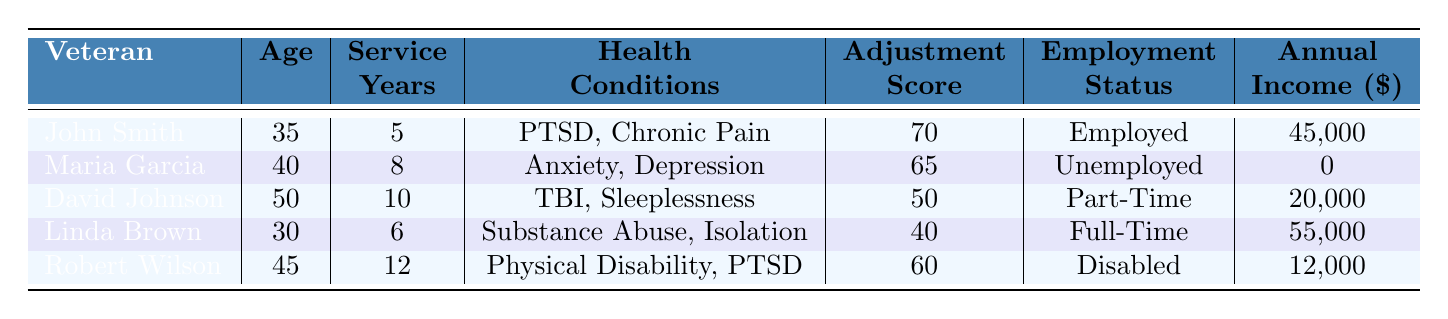What is the age of John Smith? The table shows that John Smith is listed with an age column, which indicates his age as 35.
Answer: 35 How many years did Maria Garcia serve in the military? According to the table, the entry for Maria Garcia lists her service years as 8.
Answer: 8 Which veteran has the highest adjustment score? By reviewing the adjustment scores in the table, it is clear that John Smith has the highest score of 70.
Answer: John Smith What is the average annual income of the veterans listed? To find the average income, sum the annual incomes of all veterans: (45000 + 0 + 20000 + 55000 + 12000) = 132000. There are 5 veterans, so the average is 132000 / 5 = 26400.
Answer: 26400 Is Linda Brown employed full-time? The table indicates that Linda Brown's employment status is listed as "Full-Time," which confirms she is employed full-time.
Answer: Yes What health condition is shared by both John Smith and Robert Wilson? Reviewing the health conditions listed, both veterans have PTSD listed among their conditions, indicating they share this health issue.
Answer: PTSD How many veterans have an adjustment score below 50? By examining the adjustment scores, David Johnson (50) and Linda Brown (40) are the only two veterans listed with scores below 50. Therefore, there are 2 veterans with scores below 50.
Answer: 1 What is the total number of years served by all veterans combined? To compute the total service years, add each veteran's service years: 5 + 8 + 10 + 6 + 12 = 41.
Answer: 41 Which veteran has the lowest annual income? Looking at the annual incomes, Maria Garcia has an income of $0, which is the lowest of all listed.
Answer: Maria Garcia 